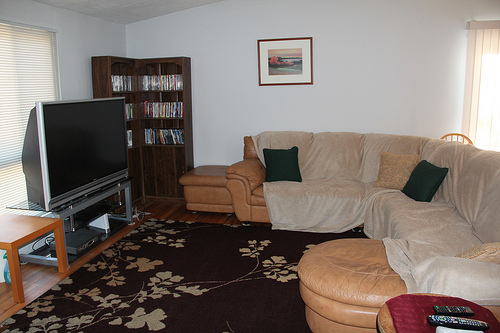Please provide a short description for this region: [0.16, 0.69, 0.34, 0.83]. This section of the image showcases a richly textured rug with an intricate floral pattern, adding a decorative touch to the room. 